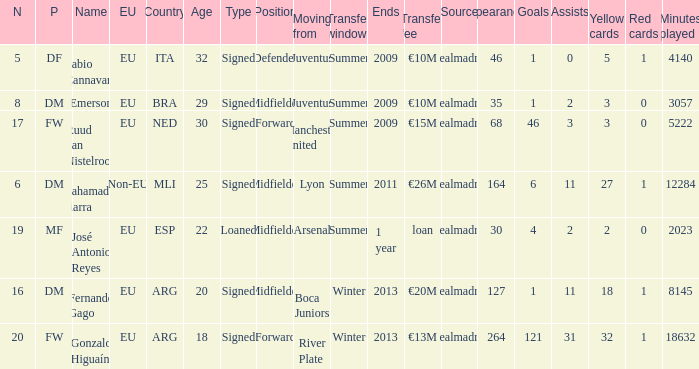What is the type of the player whose transfer fee was €20m? Signed. 